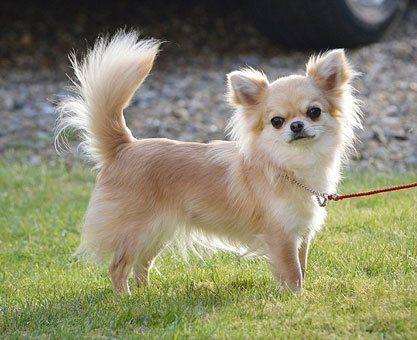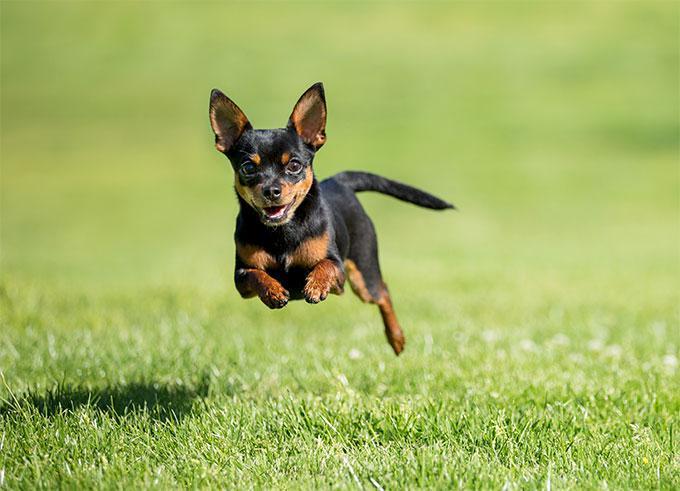The first image is the image on the left, the second image is the image on the right. Considering the images on both sides, is "There is a chihuahua on grass facing to the right and also a chihua with a darker colouring." valid? Answer yes or no. Yes. 